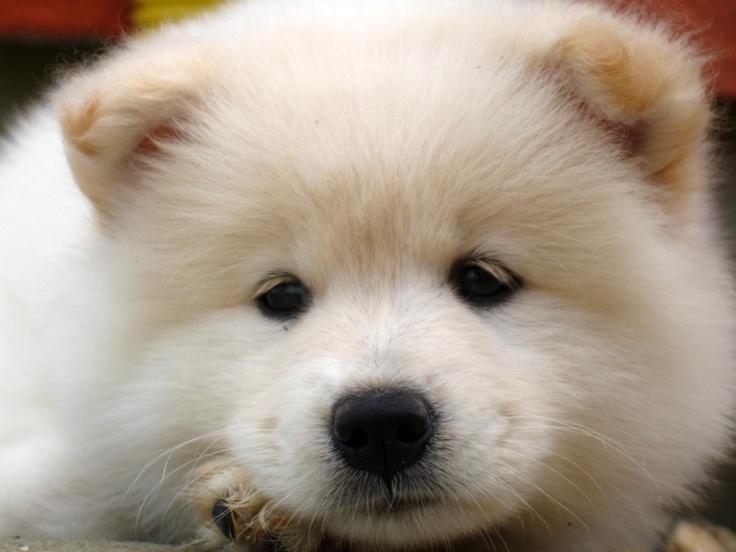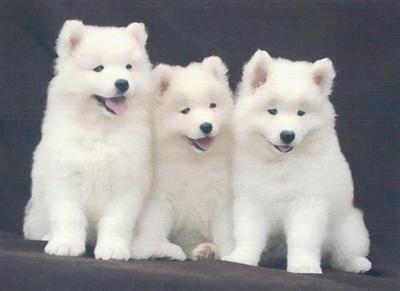The first image is the image on the left, the second image is the image on the right. Considering the images on both sides, is "There are at most 2 dogs in the image pair" valid? Answer yes or no. No. The first image is the image on the left, the second image is the image on the right. Evaluate the accuracy of this statement regarding the images: "There are at most two dogs.". Is it true? Answer yes or no. No. 